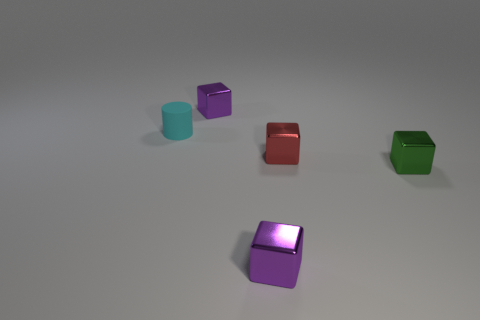Subtract all red spheres. How many purple cubes are left? 2 Subtract all green shiny cubes. How many cubes are left? 3 Subtract 2 blocks. How many blocks are left? 2 Subtract all green blocks. How many blocks are left? 3 Add 4 tiny brown blocks. How many objects exist? 9 Subtract all blocks. How many objects are left? 1 Subtract all brown cubes. Subtract all cyan spheres. How many cubes are left? 4 Add 4 small blue metallic blocks. How many small blue metallic blocks exist? 4 Subtract 0 yellow balls. How many objects are left? 5 Subtract all big cyan rubber objects. Subtract all cyan rubber cylinders. How many objects are left? 4 